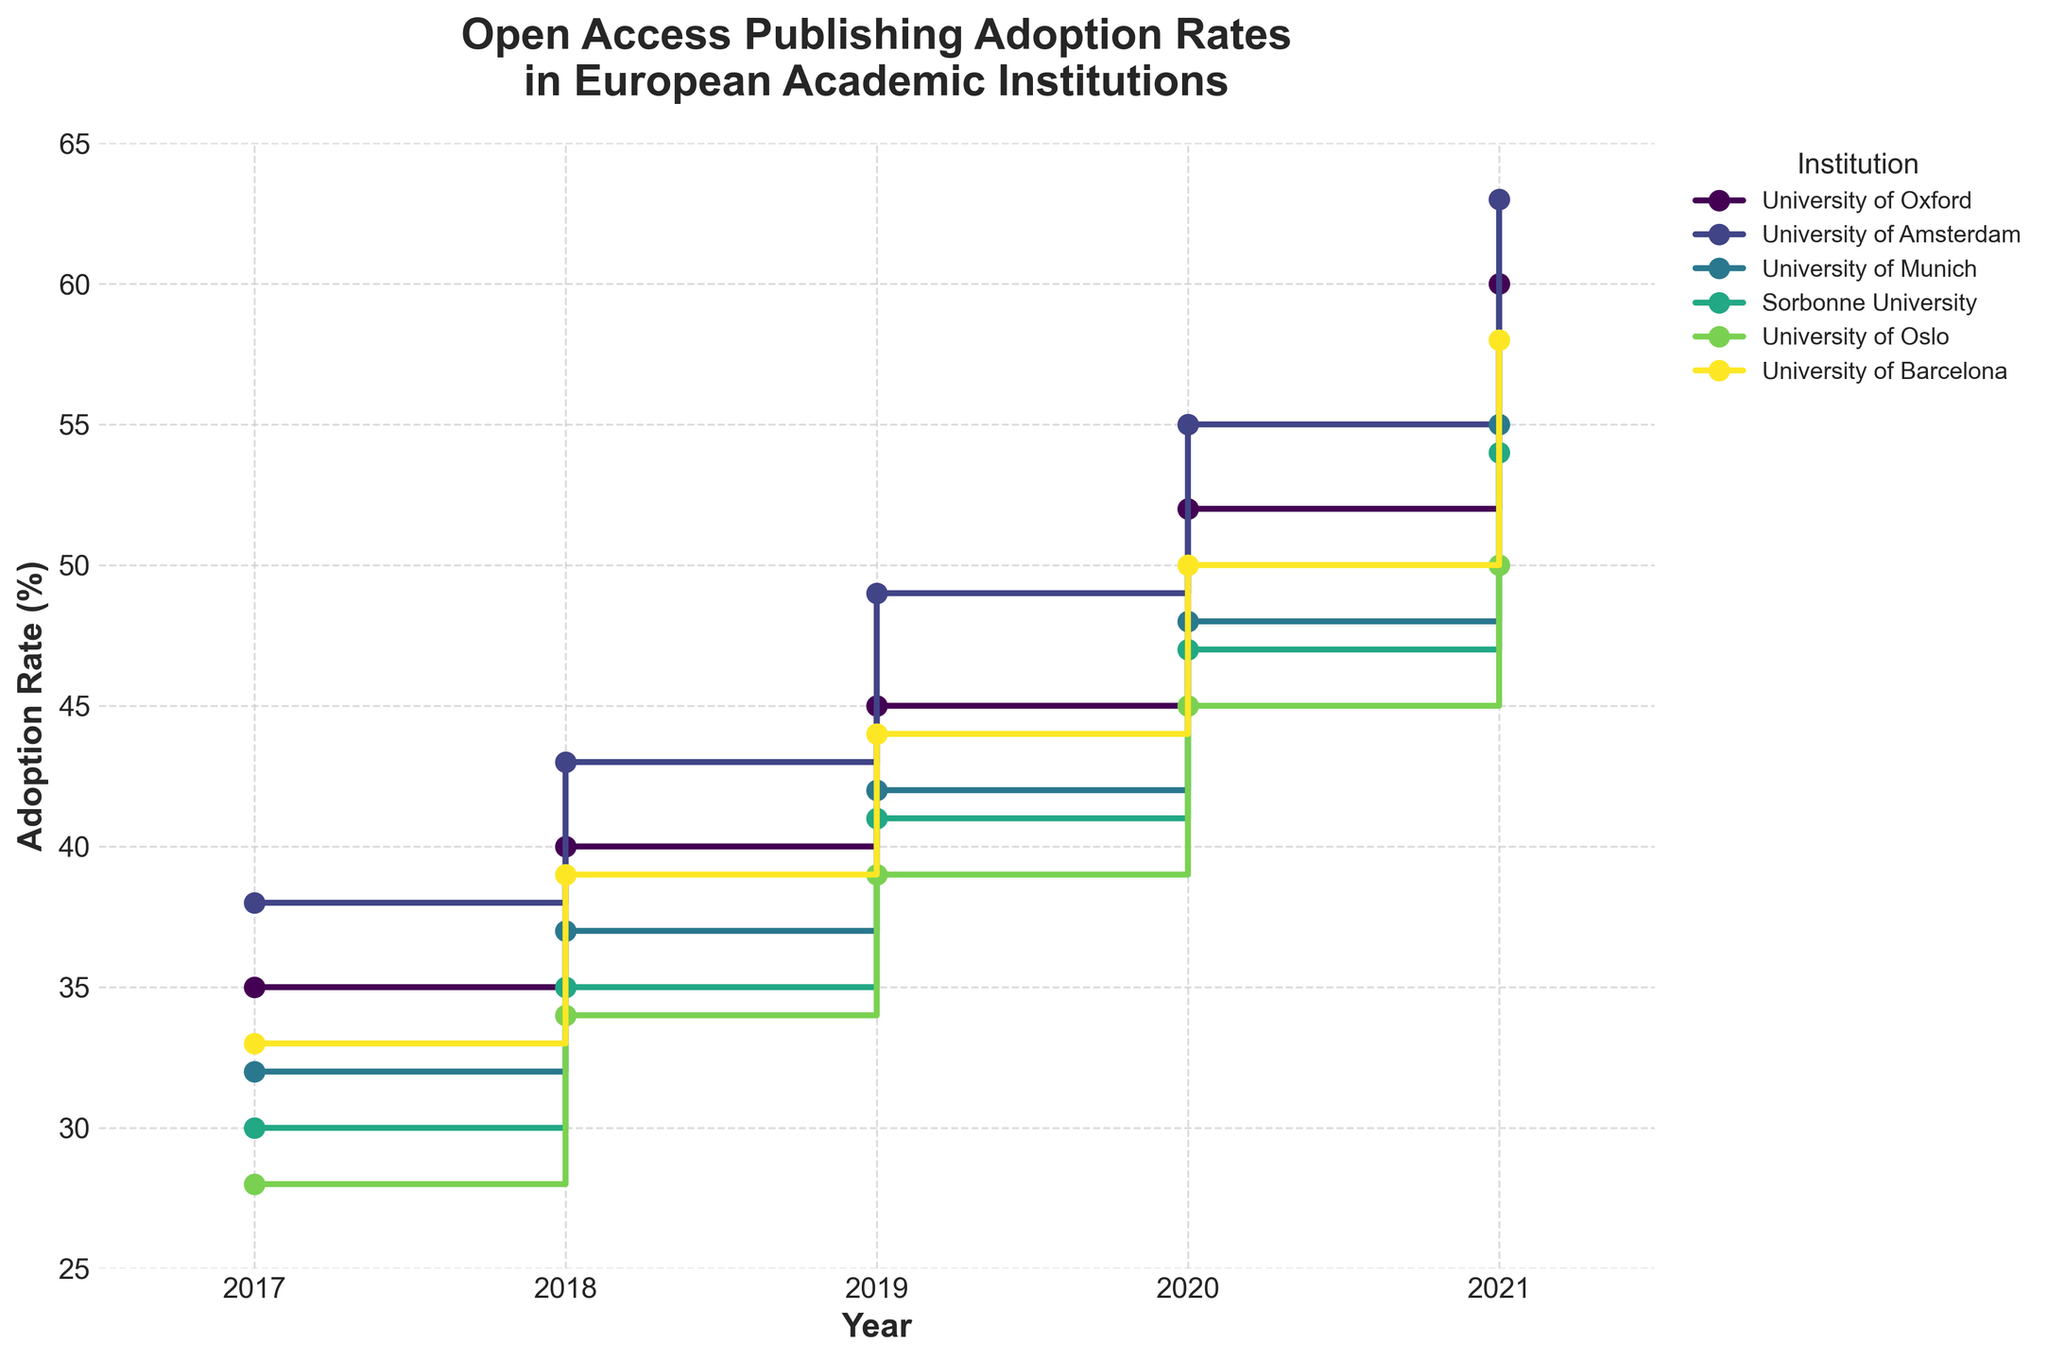What years are displayed on the x-axis? The x-axis is labeled from 2017 to 2021, with tick marks corresponding to each year in this range.
Answer: 2017-2021 Which institution has the highest adoption rate in 2021? To determine the highest adoption rate for 2021, we look at the data points for each institution in that year. The University of Amsterdam has the highest adoption rate of 63%.
Answer: University of Amsterdam What is the average adoption rate of the University of Oxford over the five years displayed? To calculate the average, sum the adoption rates of the University of Oxford from 2017 to 2021 (35 + 40 + 45 + 52 + 60) and then divide by 5. This gives (35 + 40 + 45 + 52 + 60) / 5 = 232 / 5 = 46.4%.
Answer: 46.4% Which institution shows the steepest increase in adoption rate from 2017 to 2018? The increase is calculated by subtracting the 2017 rate from the 2018 rate for each institution. University of Oslo has the steepest increase, going from 28% in 2017 to 34% in 2018, an increase of 6%.
Answer: University of Oslo Do any institutions have the same adoption rate for any year? Scanning through each institution's data points year by year, no two institutions have the same adoption rate in the same year.
Answer: No How does the adoption rate of the Sorbonne University in 2020 compare to the University of Munich in the same year? In 2020, Sorbonne University has an adoption rate of 47%, while the University of Munich has 48%. Therefore, University of Munich has a 1% higher adoption rate.
Answer: University of Munich Which institution has the most continuous year-over-year increase in its adoption rate? All institutions have some form of increase each year, but the University of Amsterdam shows a continuous rise without any dips throughout all the years.
Answer: University of Amsterdam What is the difference in adoption rates between the highest and lowest institution in 2021? In 2021, the highest adoption rate is 63% (University of Amsterdam) and the lowest is 50% (University of Oslo). Thus, the difference is 63 - 50 = 13%.
Answer: 13% Does any institution reach an adoption rate of 60% by 2021? By the year 2021, only the University of Oxford and University of Amsterdam have reached or surpassed an adoption rate of 60%, with values of 60% and 63% respectively.
Answer: Yes What is the trend of adoption rates for the University of Barcelona from 2017 to 2021? Observing the data points for the University of Barcelona, its adoption rate consistently increases each year from 33% in 2017 to 58% in 2021.
Answer: Increasing 